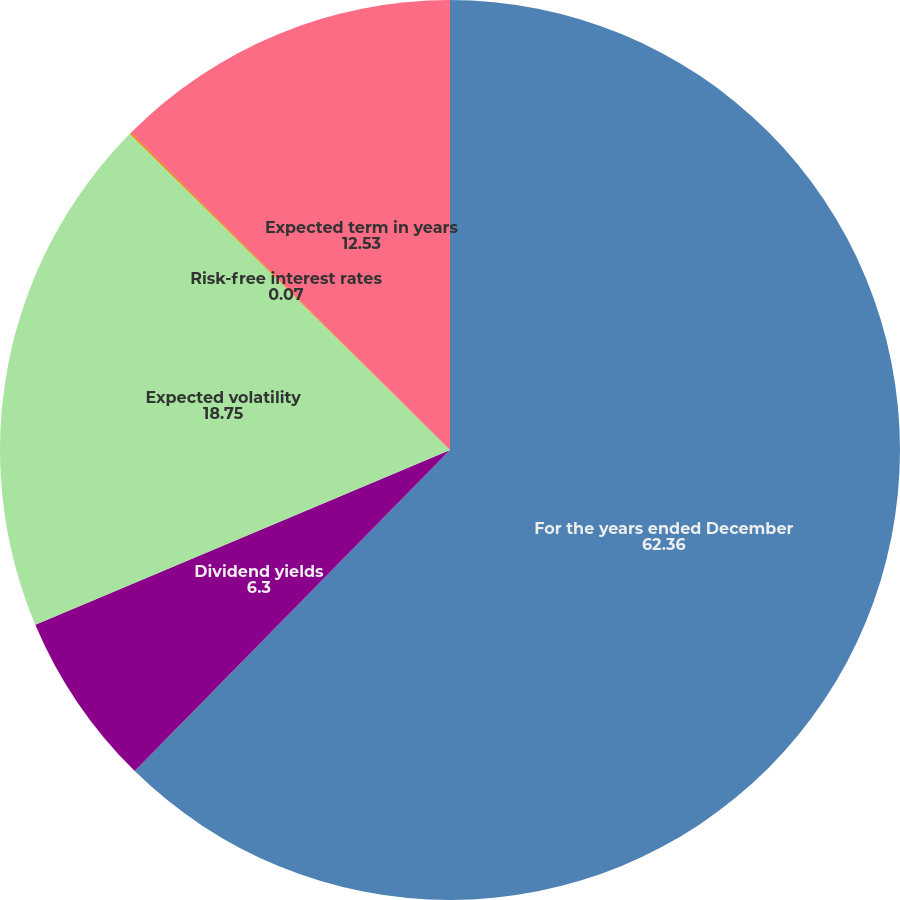Convert chart to OTSL. <chart><loc_0><loc_0><loc_500><loc_500><pie_chart><fcel>For the years ended December<fcel>Dividend yields<fcel>Expected volatility<fcel>Risk-free interest rates<fcel>Expected term in years<nl><fcel>62.36%<fcel>6.3%<fcel>18.75%<fcel>0.07%<fcel>12.53%<nl></chart> 